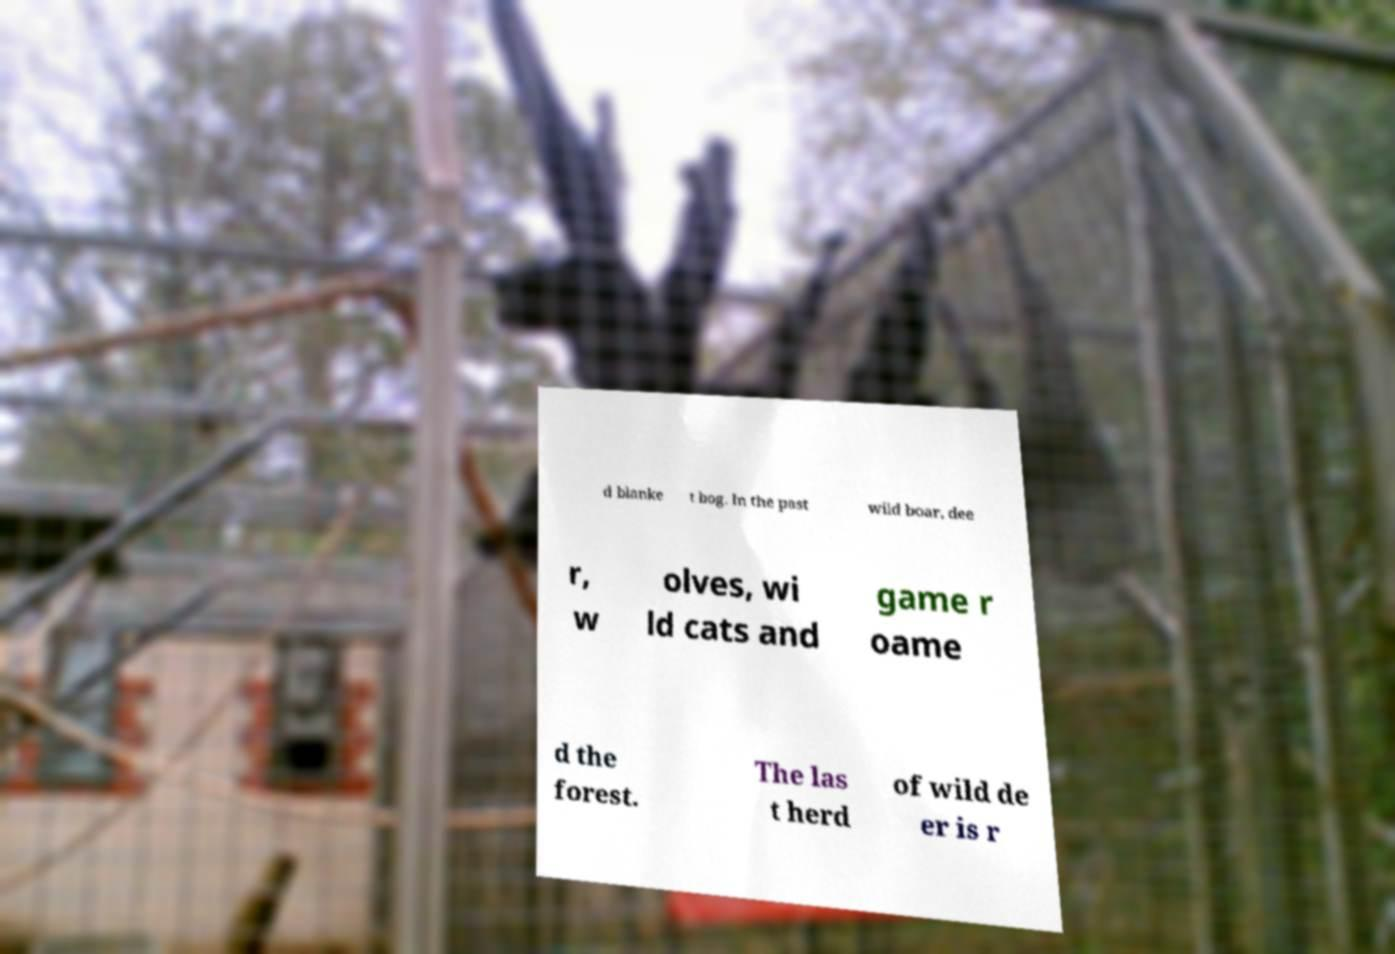For documentation purposes, I need the text within this image transcribed. Could you provide that? d blanke t bog. In the past wild boar, dee r, w olves, wi ld cats and game r oame d the forest. The las t herd of wild de er is r 